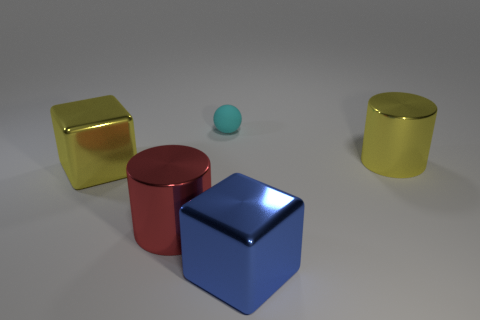Add 4 red shiny cubes. How many objects exist? 9 Subtract all blocks. How many objects are left? 3 Add 1 cyan spheres. How many cyan spheres exist? 2 Subtract 0 brown spheres. How many objects are left? 5 Subtract all big shiny objects. Subtract all small cyan rubber things. How many objects are left? 0 Add 1 blue things. How many blue things are left? 2 